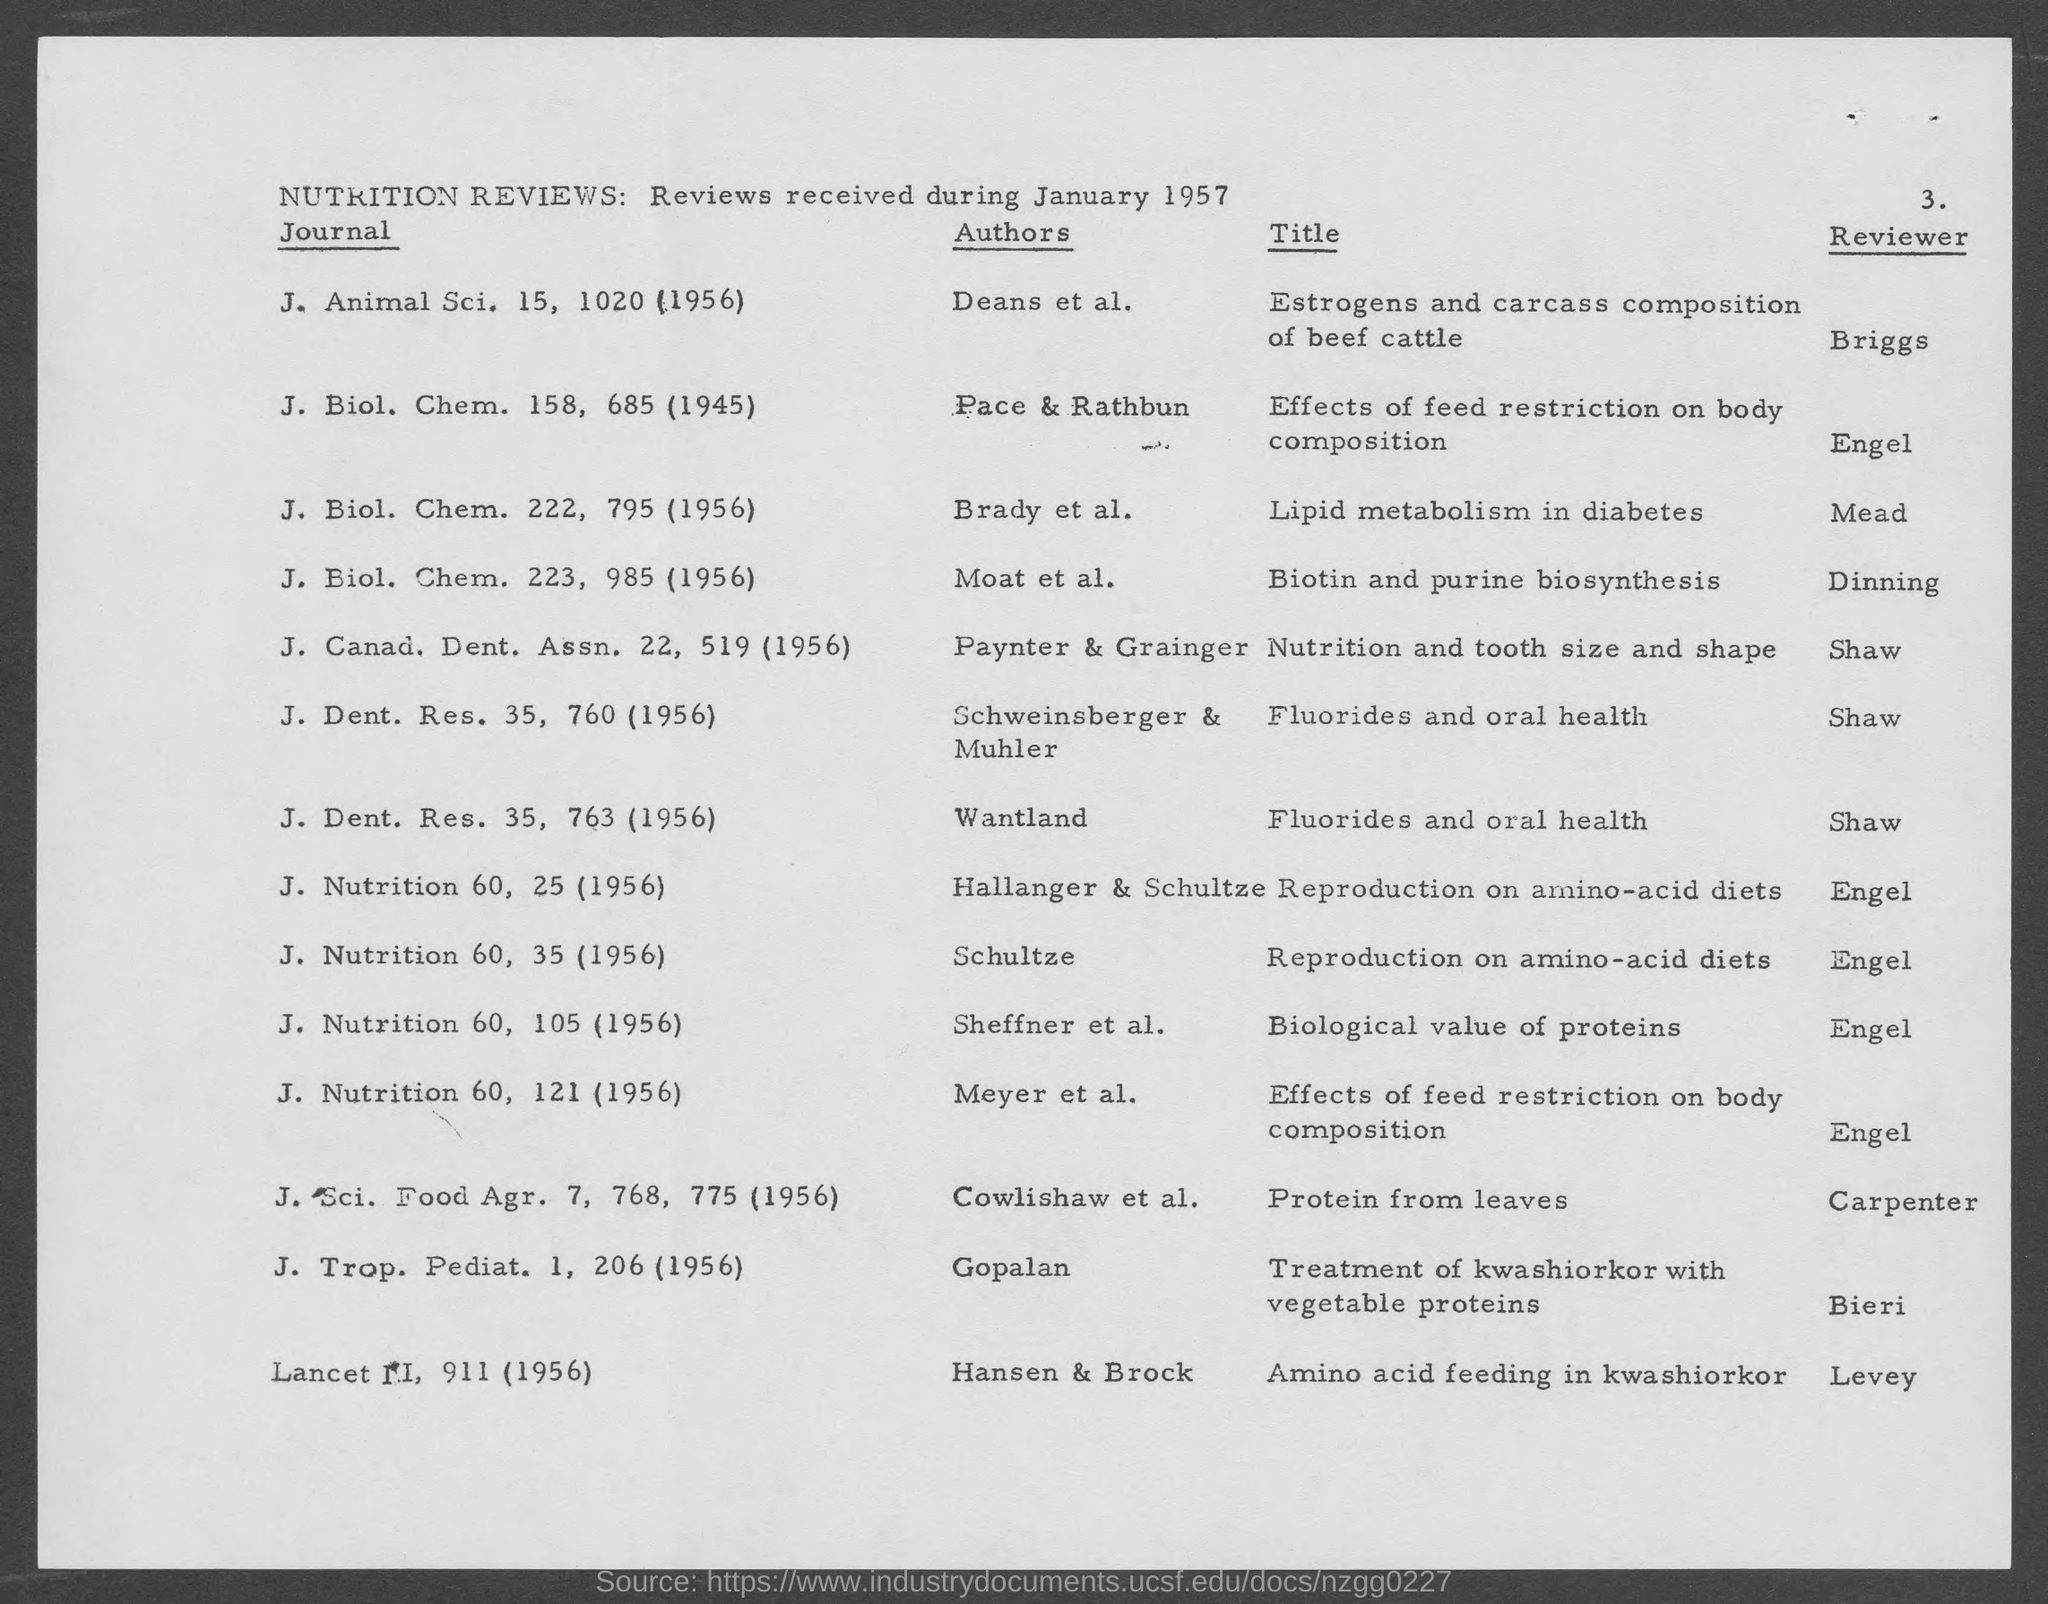Who is the author of the journal J. Nutrition 60, 35 (1956)?
Offer a terse response. Schultze. Who is the reviewer of the journal J. Nutrition 60, 35 (1956)?
Your answer should be very brief. Engel. Who is the reviewer of the journal J. Dent. Res. 35, 763 (1956)?
Your answer should be compact. Shaw. Who is the author of the journal J. Nutrition 60, 121 (1956)?
Provide a short and direct response. Meyer et al. Who is the author of the journal J. Trop. Pediat. 1, 206 (1956)?
Provide a succinct answer. Gopalan. 